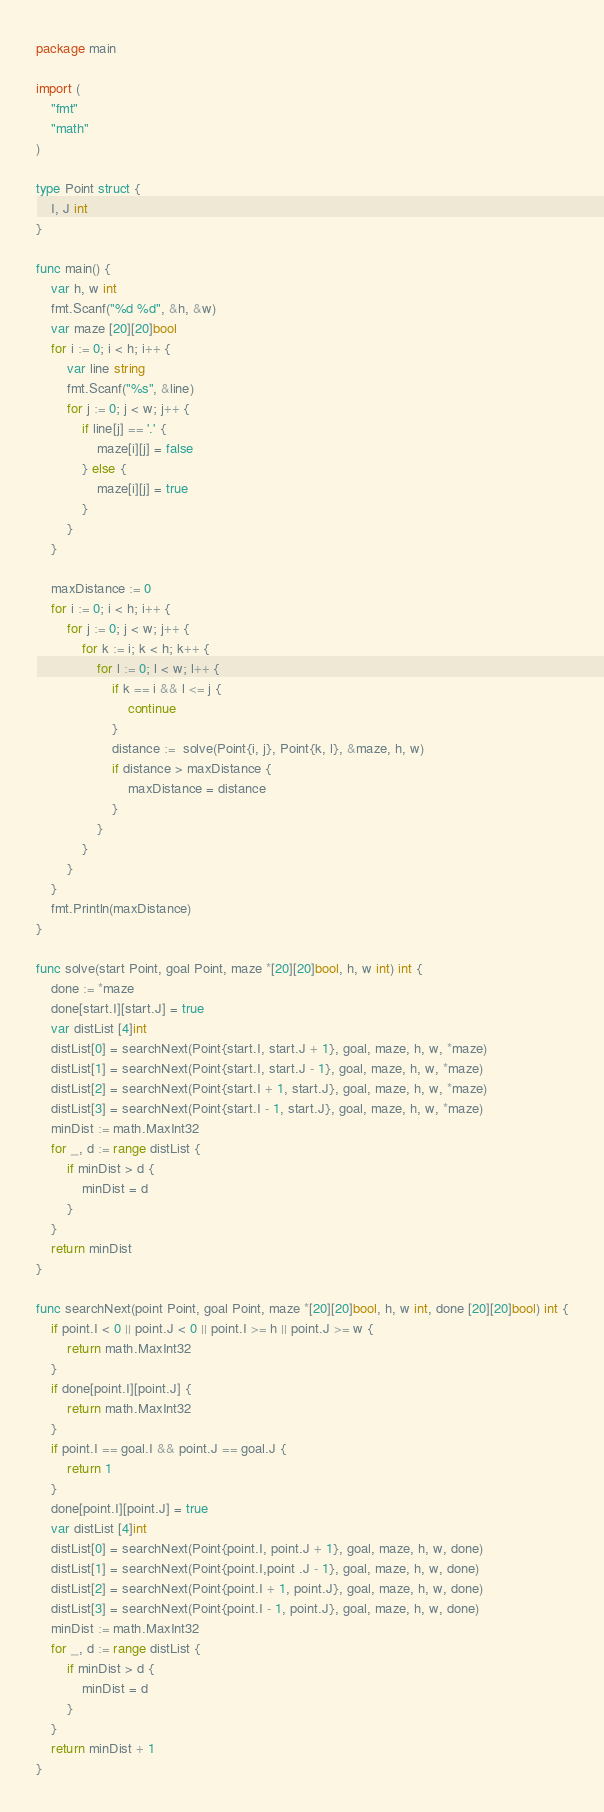<code> <loc_0><loc_0><loc_500><loc_500><_Go_>package main

import (
	"fmt"
	"math"
)

type Point struct {
	I, J int
}

func main() {
	var h, w int
	fmt.Scanf("%d %d", &h, &w)
	var maze [20][20]bool
	for i := 0; i < h; i++ {
		var line string
		fmt.Scanf("%s", &line)
		for j := 0; j < w; j++ {
			if line[j] == '.' {
				maze[i][j] = false
			} else {
				maze[i][j] = true
			}
		}
	}

	maxDistance := 0
	for i := 0; i < h; i++ {
		for j := 0; j < w; j++ {
			for k := i; k < h; k++ {
				for l := 0; l < w; l++ {
					if k == i && l <= j {
						continue
					}
					distance :=  solve(Point{i, j}, Point{k, l}, &maze, h, w)
					if distance > maxDistance {
						maxDistance = distance
					}
				}
			}
		}
	}
	fmt.Println(maxDistance)
}

func solve(start Point, goal Point, maze *[20][20]bool, h, w int) int {
	done := *maze
	done[start.I][start.J] = true
	var distList [4]int
	distList[0] = searchNext(Point{start.I, start.J + 1}, goal, maze, h, w, *maze)
	distList[1] = searchNext(Point{start.I, start.J - 1}, goal, maze, h, w, *maze)
	distList[2] = searchNext(Point{start.I + 1, start.J}, goal, maze, h, w, *maze)
	distList[3] = searchNext(Point{start.I - 1, start.J}, goal, maze, h, w, *maze)
	minDist := math.MaxInt32
	for _, d := range distList {
		if minDist > d {
			minDist = d
		}
	}
	return minDist
}

func searchNext(point Point, goal Point, maze *[20][20]bool, h, w int, done [20][20]bool) int {
	if point.I < 0 || point.J < 0 || point.I >= h || point.J >= w {
		return math.MaxInt32
	}
	if done[point.I][point.J] {
		return math.MaxInt32
	}
	if point.I == goal.I && point.J == goal.J {
		return 1
	}
	done[point.I][point.J] = true
	var distList [4]int
	distList[0] = searchNext(Point{point.I, point.J + 1}, goal, maze, h, w, done)
	distList[1] = searchNext(Point{point.I,point .J - 1}, goal, maze, h, w, done)
	distList[2] = searchNext(Point{point.I + 1, point.J}, goal, maze, h, w, done)
	distList[3] = searchNext(Point{point.I - 1, point.J}, goal, maze, h, w, done)
	minDist := math.MaxInt32
	for _, d := range distList {
		if minDist > d {
			minDist = d
		}
	}
	return minDist + 1
}

</code> 